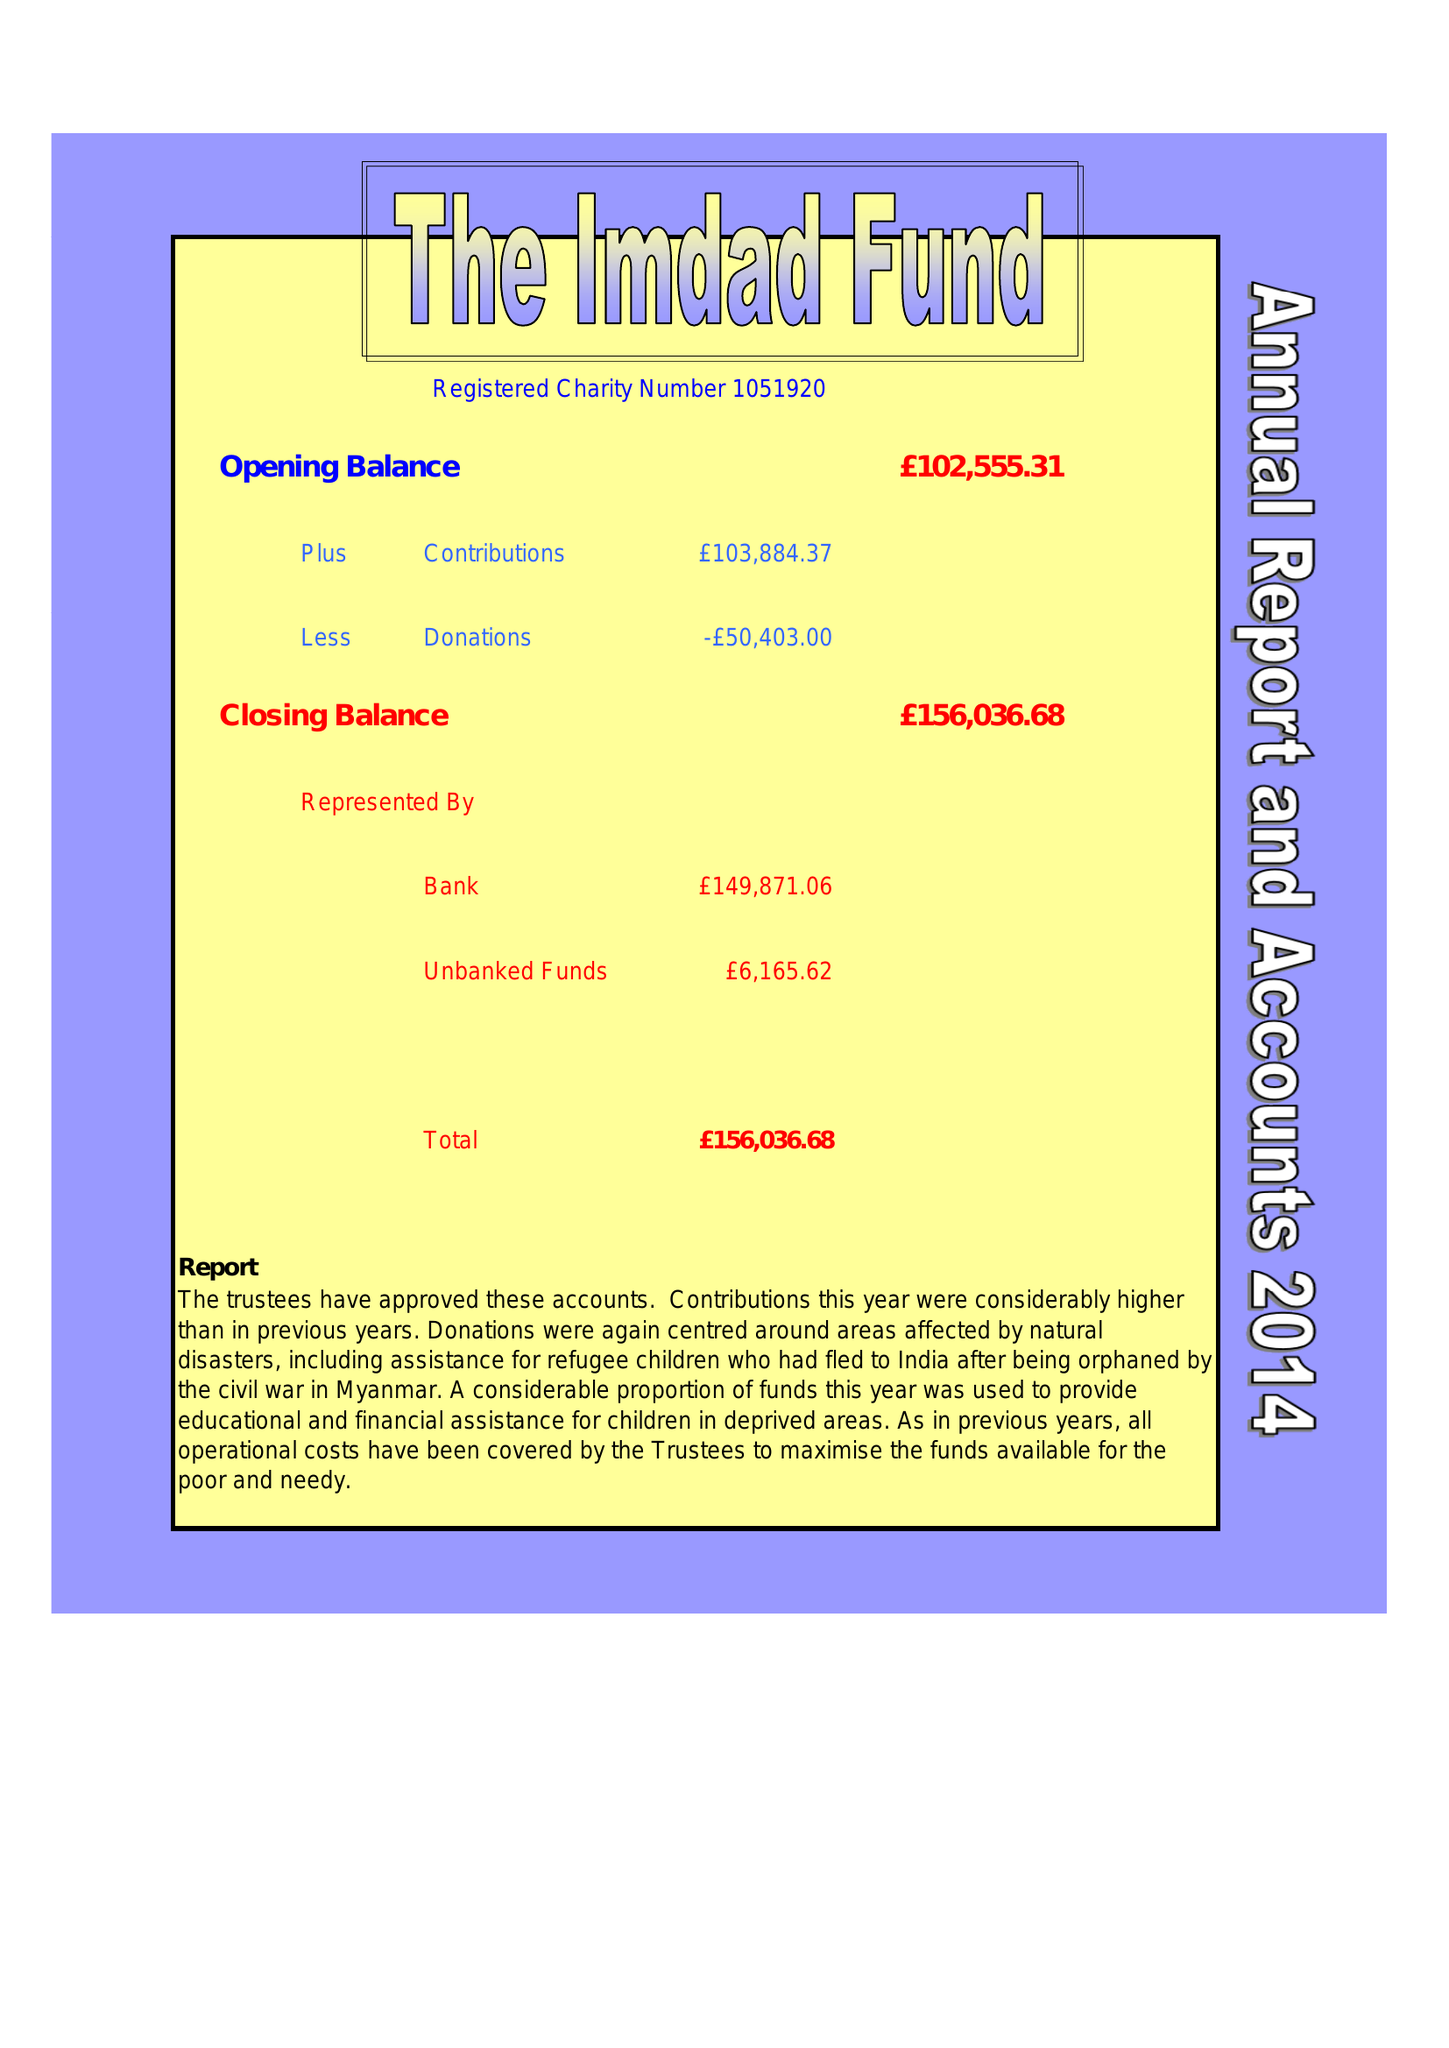What is the value for the charity_number?
Answer the question using a single word or phrase. 1051920 